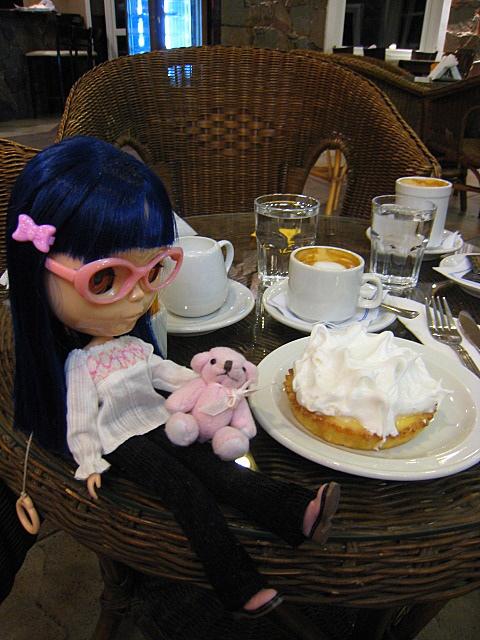How do you make the toy doll do something?
Give a very brief answer. Pull string. What color is the wall?
Be succinct. Brown. Would you say there is a child sitting at this table?
Be succinct. Yes. What colors are the frosting?
Quick response, please. White. What does the big word say on the teddy bears shirt?
Give a very brief answer. Nothing. Are there eggs on the table?
Give a very brief answer. No. What kind of drinks are on the table?
Concise answer only. Water. What color is the teddy bear?
Short answer required. Pink. What character is this?
Keep it brief. Doll. 